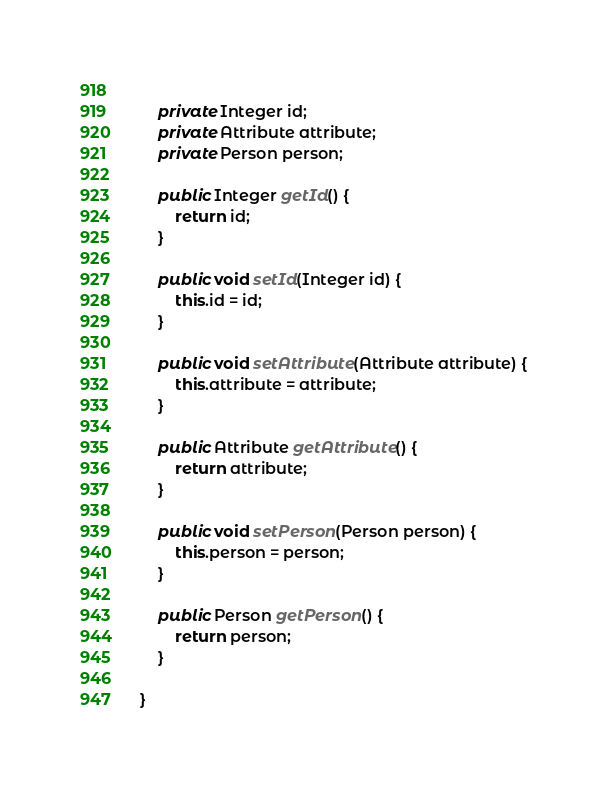Convert code to text. <code><loc_0><loc_0><loc_500><loc_500><_Java_>	
	private Integer id;
	private Attribute attribute;
	private Person person;

	public Integer getId() {
		return id;
	}

	public void setId(Integer id) {
		this.id = id;
	}

	public void setAttribute(Attribute attribute) {
		this.attribute = attribute;
	}

	public Attribute getAttribute() {
		return attribute;
	}

	public void setPerson(Person person) {
		this.person = person;
	}

	public Person getPerson() {
		return person;
	}

}
</code> 